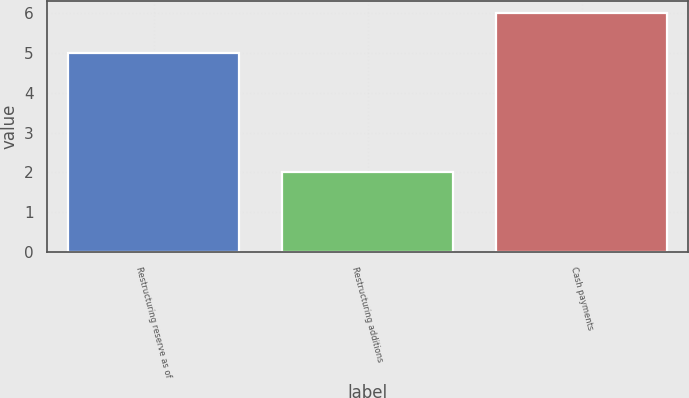Convert chart. <chart><loc_0><loc_0><loc_500><loc_500><bar_chart><fcel>Restructuring reserve as of<fcel>Restructuring additions<fcel>Cash payments<nl><fcel>5<fcel>2<fcel>6<nl></chart> 